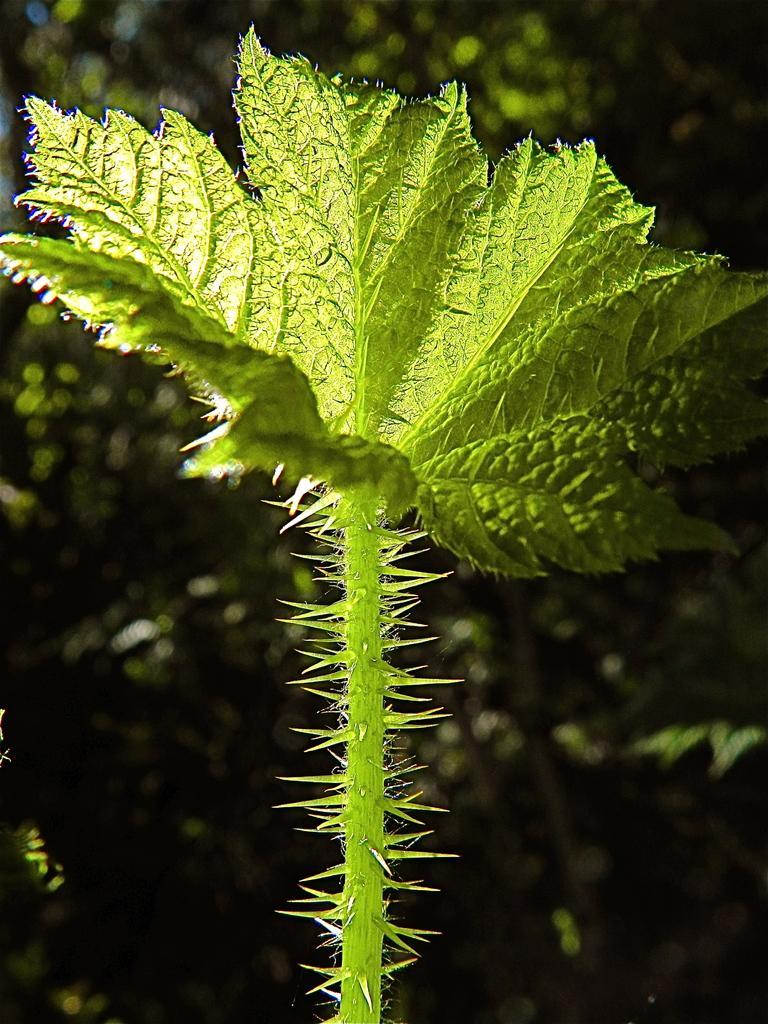How would you summarize this image in a sentence or two? This picture contains a plant which has thorns and leaves. In the background, there are trees and it is blurred in the background. 